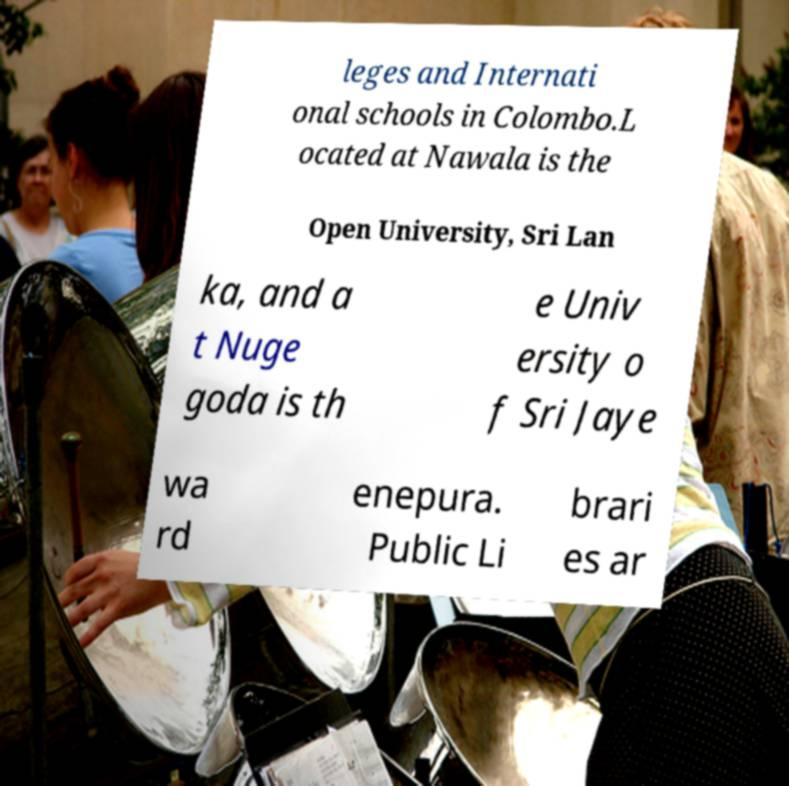There's text embedded in this image that I need extracted. Can you transcribe it verbatim? leges and Internati onal schools in Colombo.L ocated at Nawala is the Open University, Sri Lan ka, and a t Nuge goda is th e Univ ersity o f Sri Jaye wa rd enepura. Public Li brari es ar 